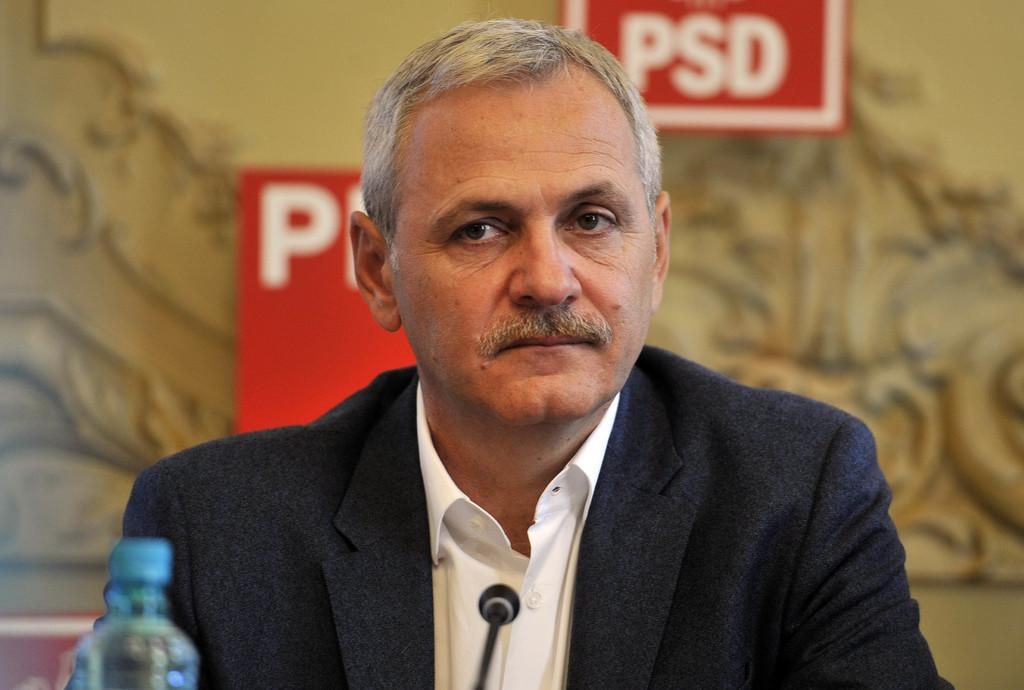What is the main subject of the image? The main subject of the image is a man. What is the man doing in the image? The man is in front of a microphone. What other object is visible in the image? There is a bottle in the image. What type of surface is the man and the microphone placed on? The image is of a board. What is the man using to reach the moon in the image? There is no indication in the image that the man is trying to reach the moon, nor is there any object present that could be used for that purpose. 